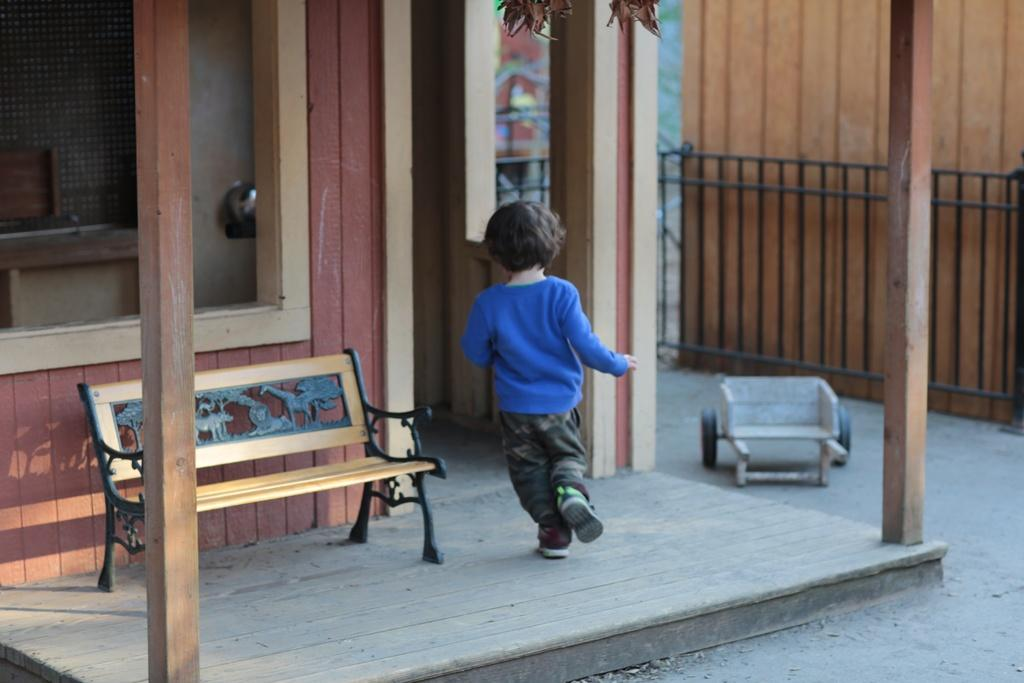What is the main subject of the image? There is a child in the image. What is the child sitting on in the image? There is a bench in the image. What can be seen in the background of the image? There is a house and a fence in the background of the image. What type of cast is the child wearing on their arm in the image? There is no cast visible on the child's arm in the image. 